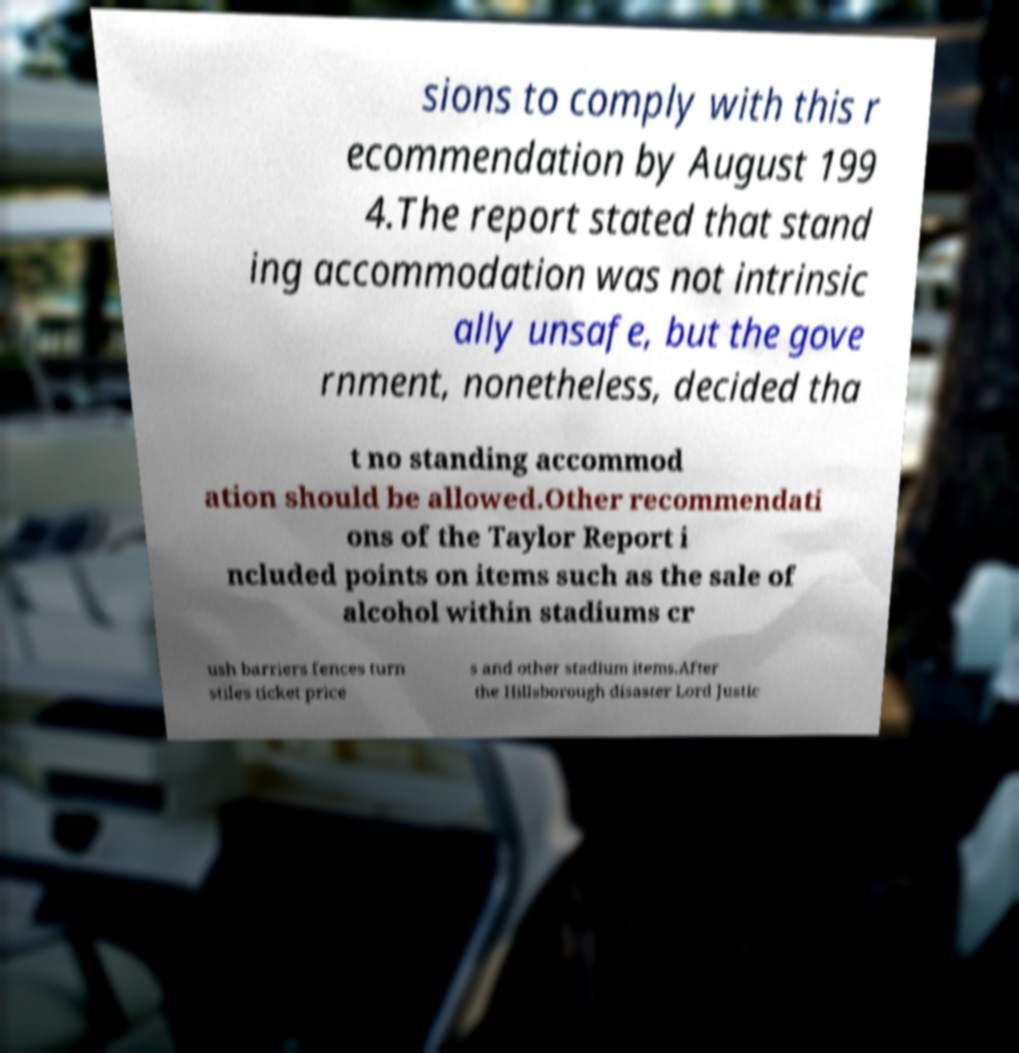Could you assist in decoding the text presented in this image and type it out clearly? sions to comply with this r ecommendation by August 199 4.The report stated that stand ing accommodation was not intrinsic ally unsafe, but the gove rnment, nonetheless, decided tha t no standing accommod ation should be allowed.Other recommendati ons of the Taylor Report i ncluded points on items such as the sale of alcohol within stadiums cr ush barriers fences turn stiles ticket price s and other stadium items.After the Hillsborough disaster Lord Justic 